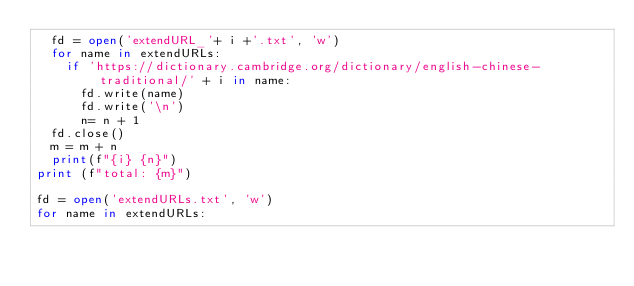<code> <loc_0><loc_0><loc_500><loc_500><_Python_>	fd = open('extendURL_'+ i +'.txt', 'w')
	for name in extendURLs:
		if 'https://dictionary.cambridge.org/dictionary/english-chinese-traditional/' + i in name:
			fd.write(name)
			fd.write('\n')
			n= n + 1
	fd.close()
	m = m + n
	print(f"{i} {n}")
print (f"total: {m}")

fd = open('extendURLs.txt', 'w')
for name in extendURLs:</code> 